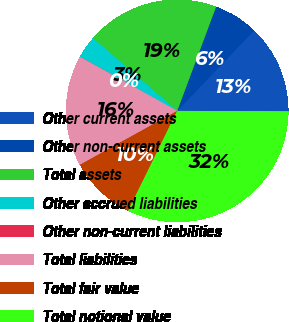Convert chart. <chart><loc_0><loc_0><loc_500><loc_500><pie_chart><fcel>Other current assets<fcel>Other non-current assets<fcel>Total assets<fcel>Other accrued liabilities<fcel>Other non-current liabilities<fcel>Total liabilities<fcel>Total fair value<fcel>Total notional value<nl><fcel>12.9%<fcel>6.47%<fcel>19.34%<fcel>3.25%<fcel>0.03%<fcel>16.12%<fcel>9.68%<fcel>32.21%<nl></chart> 